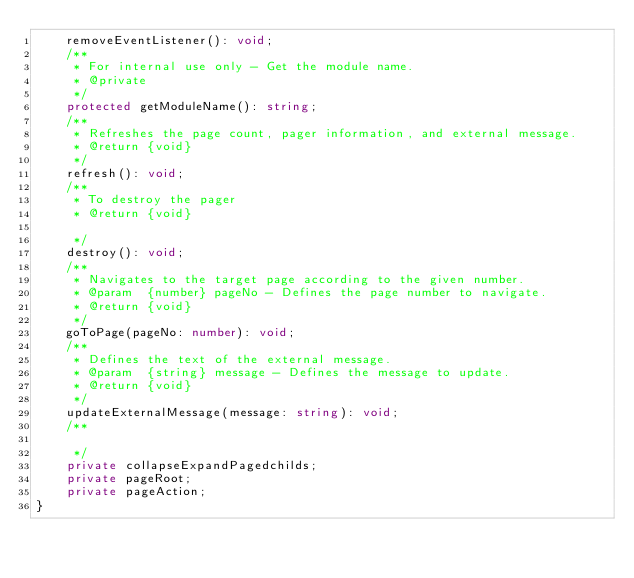Convert code to text. <code><loc_0><loc_0><loc_500><loc_500><_TypeScript_>    removeEventListener(): void;
    /**
     * For internal use only - Get the module name.
     * @private
     */
    protected getModuleName(): string;
    /**
     * Refreshes the page count, pager information, and external message.
     * @return {void}
     */
    refresh(): void;
    /**
     * To destroy the pager
     * @return {void}

     */
    destroy(): void;
    /**
     * Navigates to the target page according to the given number.
     * @param  {number} pageNo - Defines the page number to navigate.
     * @return {void}
     */
    goToPage(pageNo: number): void;
    /**
     * Defines the text of the external message.
     * @param  {string} message - Defines the message to update.
     * @return {void}
     */
    updateExternalMessage(message: string): void;
    /**

     */
    private collapseExpandPagedchilds;
    private pageRoot;
    private pageAction;
}
</code> 